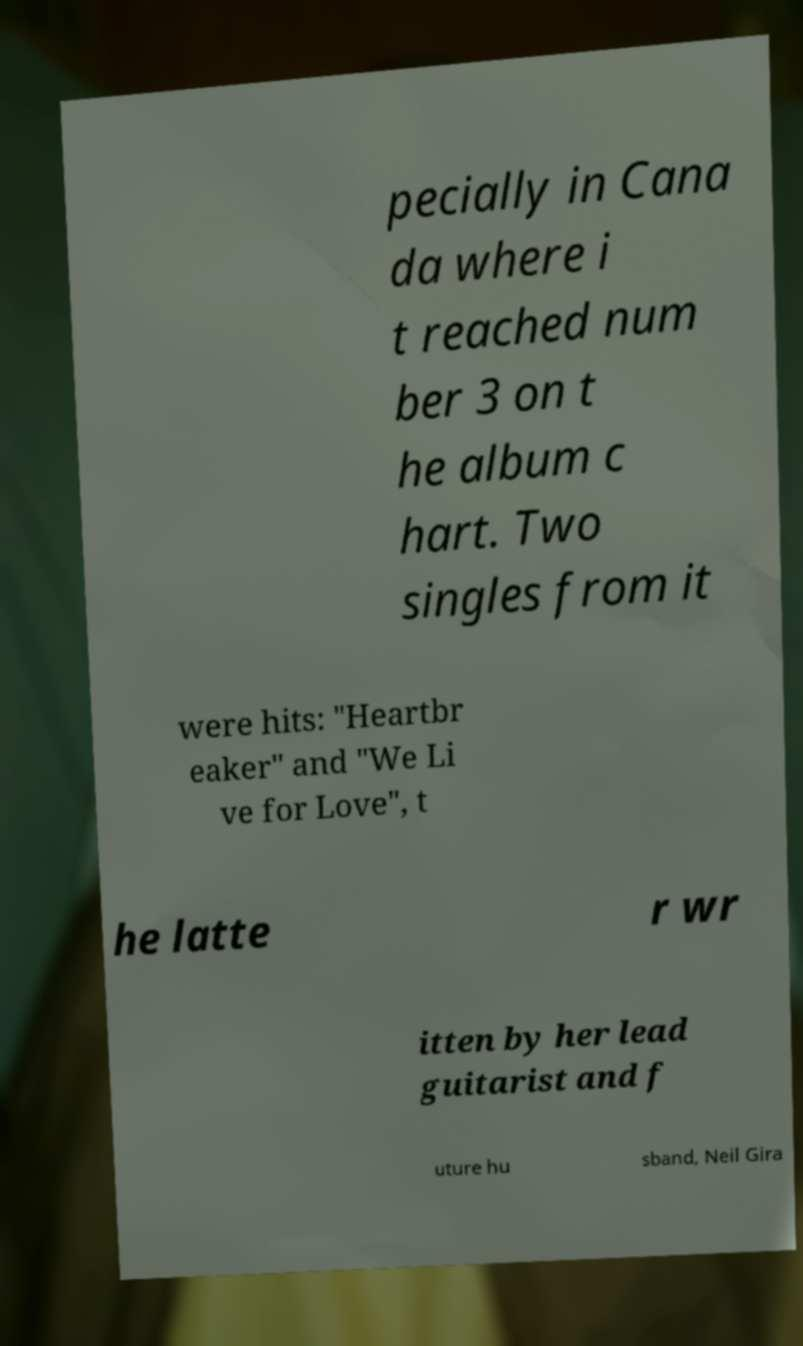Could you assist in decoding the text presented in this image and type it out clearly? pecially in Cana da where i t reached num ber 3 on t he album c hart. Two singles from it were hits: "Heartbr eaker" and "We Li ve for Love", t he latte r wr itten by her lead guitarist and f uture hu sband, Neil Gira 